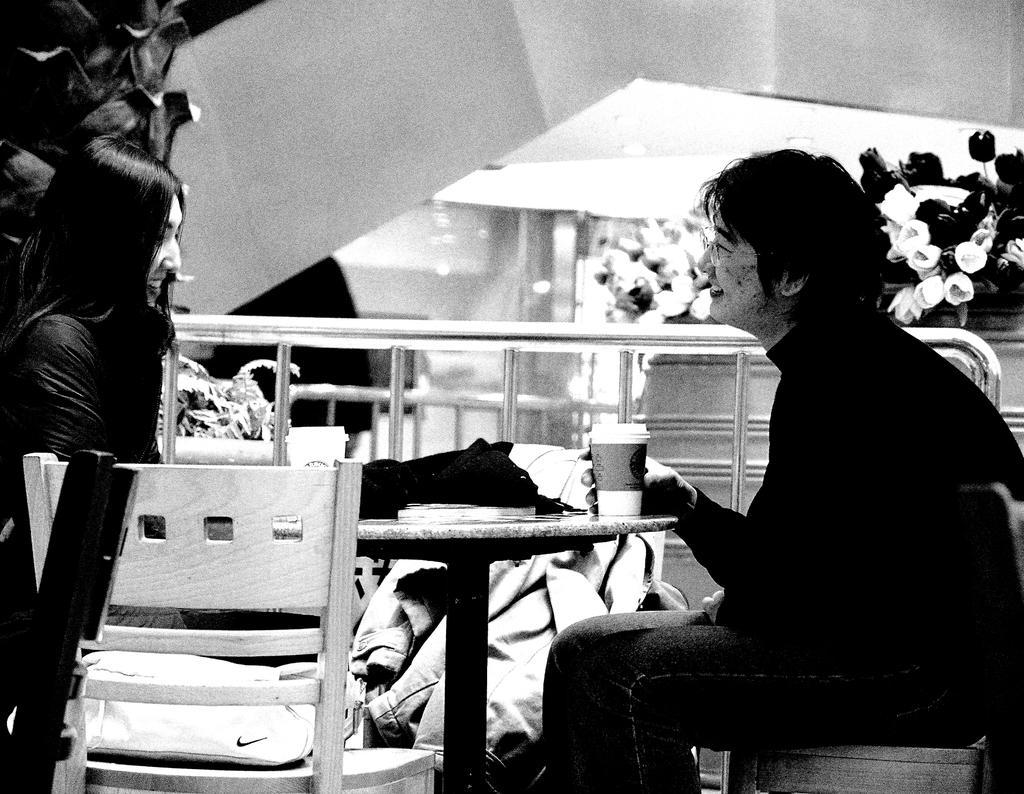In one or two sentences, can you explain what this image depicts? In the right side a person is sitting, this person wore a black color dress and also holding a cup on the table. In the left side a beautiful girl is sitting. 